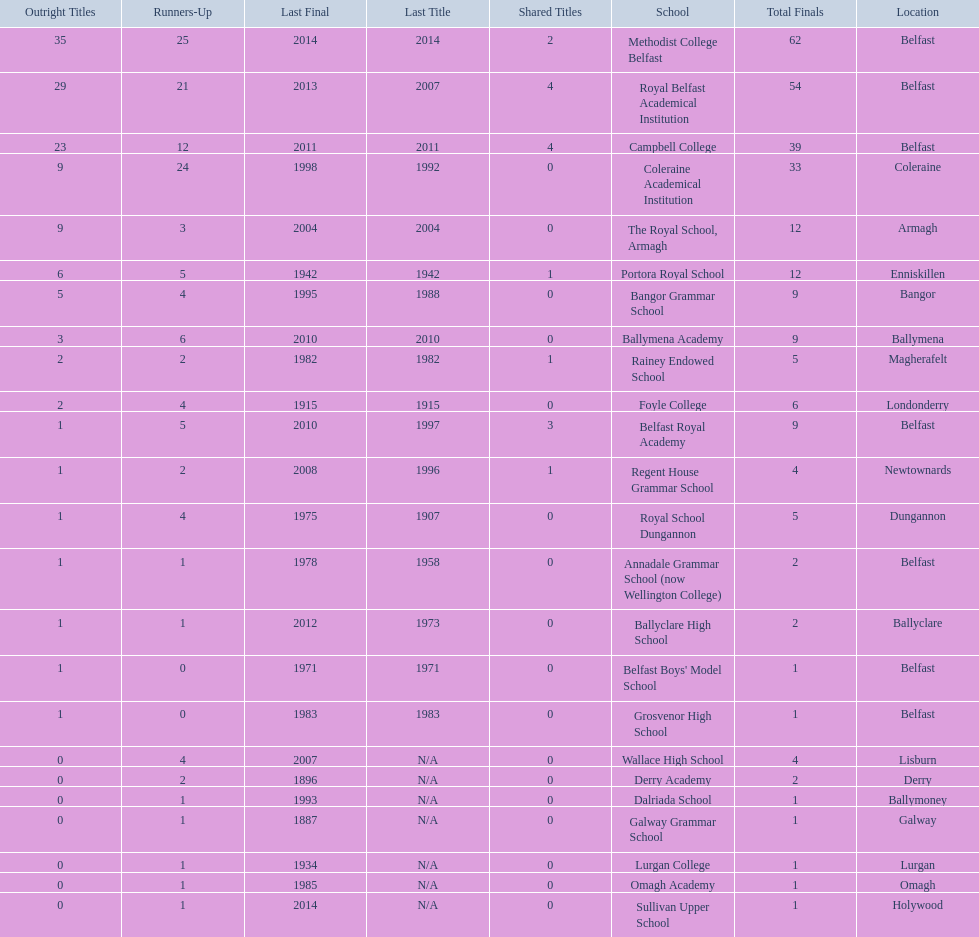I'm looking to parse the entire table for insights. Could you assist me with that? {'header': ['Outright Titles', 'Runners-Up', 'Last Final', 'Last Title', 'Shared Titles', 'School', 'Total Finals', 'Location'], 'rows': [['35', '25', '2014', '2014', '2', 'Methodist College Belfast', '62', 'Belfast'], ['29', '21', '2013', '2007', '4', 'Royal Belfast Academical Institution', '54', 'Belfast'], ['23', '12', '2011', '2011', '4', 'Campbell College', '39', 'Belfast'], ['9', '24', '1998', '1992', '0', 'Coleraine Academical Institution', '33', 'Coleraine'], ['9', '3', '2004', '2004', '0', 'The Royal School, Armagh', '12', 'Armagh'], ['6', '5', '1942', '1942', '1', 'Portora Royal School', '12', 'Enniskillen'], ['5', '4', '1995', '1988', '0', 'Bangor Grammar School', '9', 'Bangor'], ['3', '6', '2010', '2010', '0', 'Ballymena Academy', '9', 'Ballymena'], ['2', '2', '1982', '1982', '1', 'Rainey Endowed School', '5', 'Magherafelt'], ['2', '4', '1915', '1915', '0', 'Foyle College', '6', 'Londonderry'], ['1', '5', '2010', '1997', '3', 'Belfast Royal Academy', '9', 'Belfast'], ['1', '2', '2008', '1996', '1', 'Regent House Grammar School', '4', 'Newtownards'], ['1', '4', '1975', '1907', '0', 'Royal School Dungannon', '5', 'Dungannon'], ['1', '1', '1978', '1958', '0', 'Annadale Grammar School (now Wellington College)', '2', 'Belfast'], ['1', '1', '2012', '1973', '0', 'Ballyclare High School', '2', 'Ballyclare'], ['1', '0', '1971', '1971', '0', "Belfast Boys' Model School", '1', 'Belfast'], ['1', '0', '1983', '1983', '0', 'Grosvenor High School', '1', 'Belfast'], ['0', '4', '2007', 'N/A', '0', 'Wallace High School', '4', 'Lisburn'], ['0', '2', '1896', 'N/A', '0', 'Derry Academy', '2', 'Derry'], ['0', '1', '1993', 'N/A', '0', 'Dalriada School', '1', 'Ballymoney'], ['0', '1', '1887', 'N/A', '0', 'Galway Grammar School', '1', 'Galway'], ['0', '1', '1934', 'N/A', '0', 'Lurgan College', '1', 'Lurgan'], ['0', '1', '1985', 'N/A', '0', 'Omagh Academy', '1', 'Omagh'], ['0', '1', '2014', 'N/A', '0', 'Sullivan Upper School', '1', 'Holywood']]} What number of total finals does foyle college have? 6. 